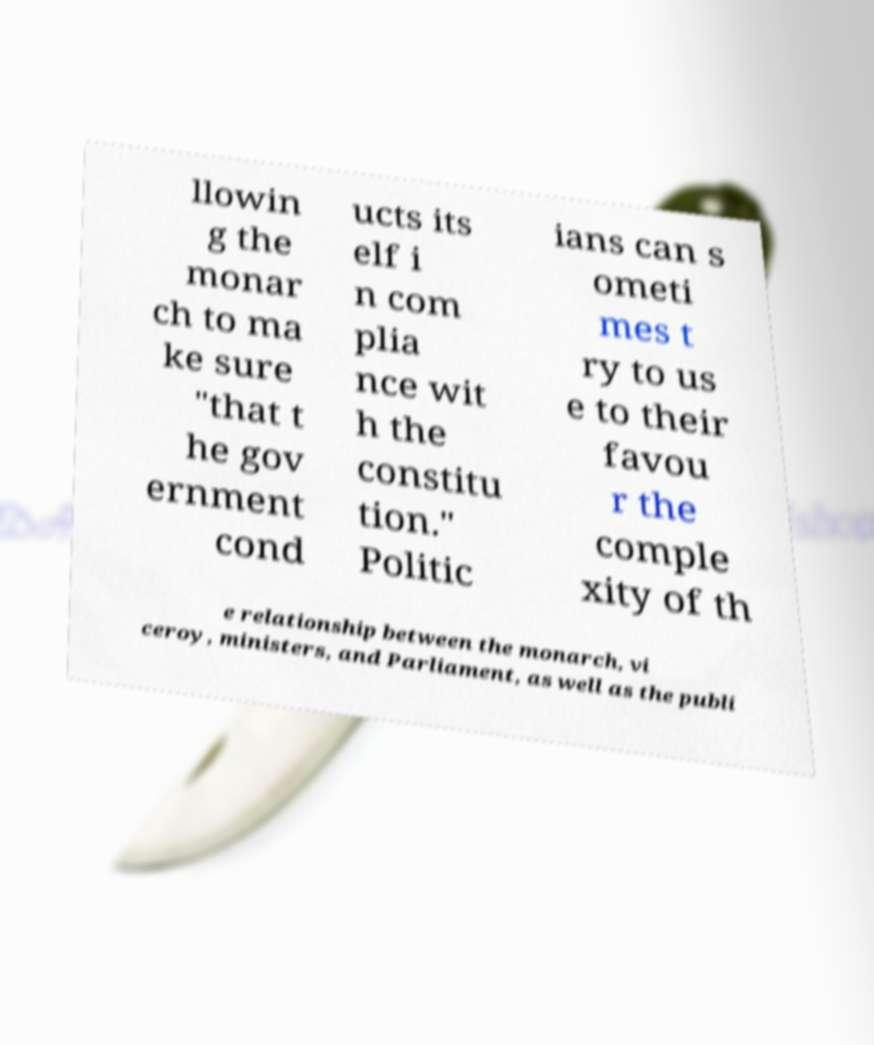There's text embedded in this image that I need extracted. Can you transcribe it verbatim? llowin g the monar ch to ma ke sure "that t he gov ernment cond ucts its elf i n com plia nce wit h the constitu tion." Politic ians can s ometi mes t ry to us e to their favou r the comple xity of th e relationship between the monarch, vi ceroy, ministers, and Parliament, as well as the publi 